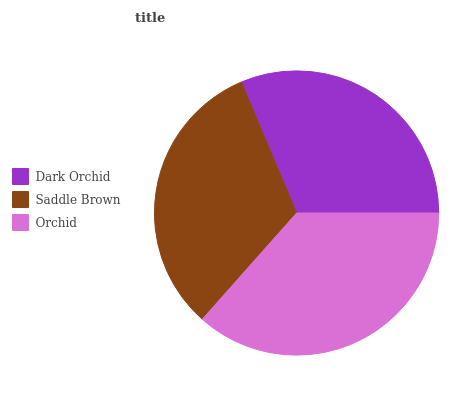Is Dark Orchid the minimum?
Answer yes or no. Yes. Is Orchid the maximum?
Answer yes or no. Yes. Is Saddle Brown the minimum?
Answer yes or no. No. Is Saddle Brown the maximum?
Answer yes or no. No. Is Saddle Brown greater than Dark Orchid?
Answer yes or no. Yes. Is Dark Orchid less than Saddle Brown?
Answer yes or no. Yes. Is Dark Orchid greater than Saddle Brown?
Answer yes or no. No. Is Saddle Brown less than Dark Orchid?
Answer yes or no. No. Is Saddle Brown the high median?
Answer yes or no. Yes. Is Saddle Brown the low median?
Answer yes or no. Yes. Is Orchid the high median?
Answer yes or no. No. Is Orchid the low median?
Answer yes or no. No. 